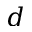<formula> <loc_0><loc_0><loc_500><loc_500>d</formula> 